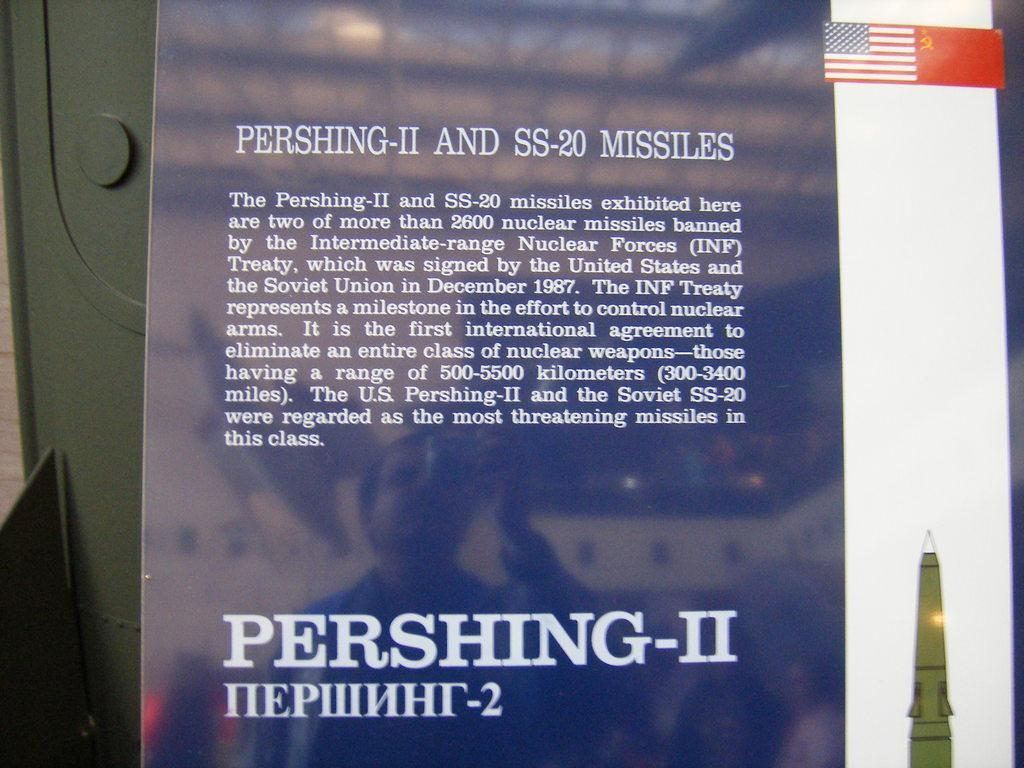<image>
Give a short and clear explanation of the subsequent image. A blue and white sign explaining the Pershing-II and SS-20 Missiles. 